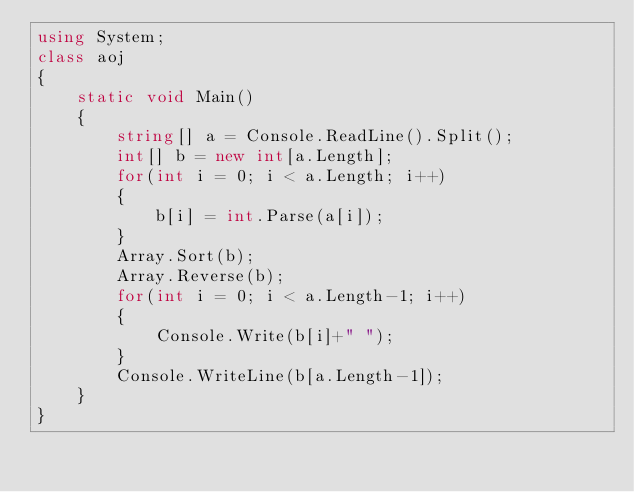Convert code to text. <code><loc_0><loc_0><loc_500><loc_500><_C#_>using System;
class aoj
{
    static void Main()
    {
        string[] a = Console.ReadLine().Split();
        int[] b = new int[a.Length];
        for(int i = 0; i < a.Length; i++)
        {
            b[i] = int.Parse(a[i]);
        }
        Array.Sort(b);
        Array.Reverse(b);
        for(int i = 0; i < a.Length-1; i++)
        {
            Console.Write(b[i]+" ");
        } 
        Console.WriteLine(b[a.Length-1]);
    }
}</code> 